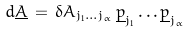<formula> <loc_0><loc_0><loc_500><loc_500>d { \underline { A } } \, = \, \delta A _ { j _ { 1 } \dots j _ { \alpha } } \, { \underline { p } } _ { j _ { 1 } } \dots { \underline { p } } _ { j _ { \alpha } }</formula> 